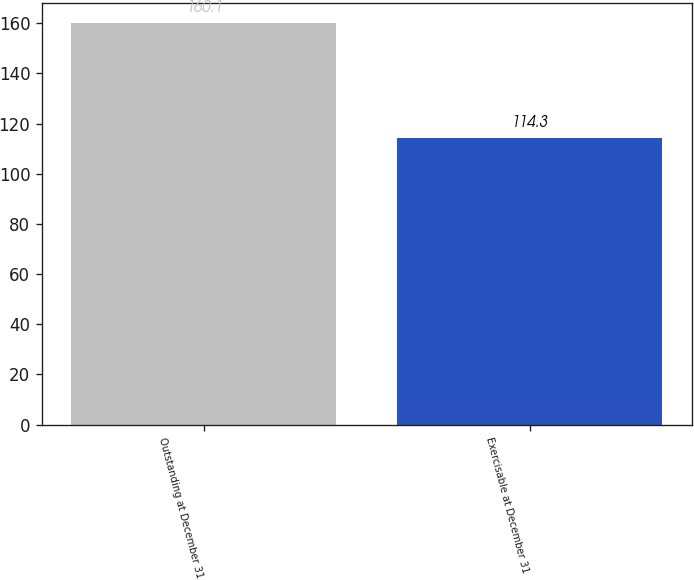Convert chart. <chart><loc_0><loc_0><loc_500><loc_500><bar_chart><fcel>Outstanding at December 31<fcel>Exercisable at December 31<nl><fcel>160.1<fcel>114.3<nl></chart> 